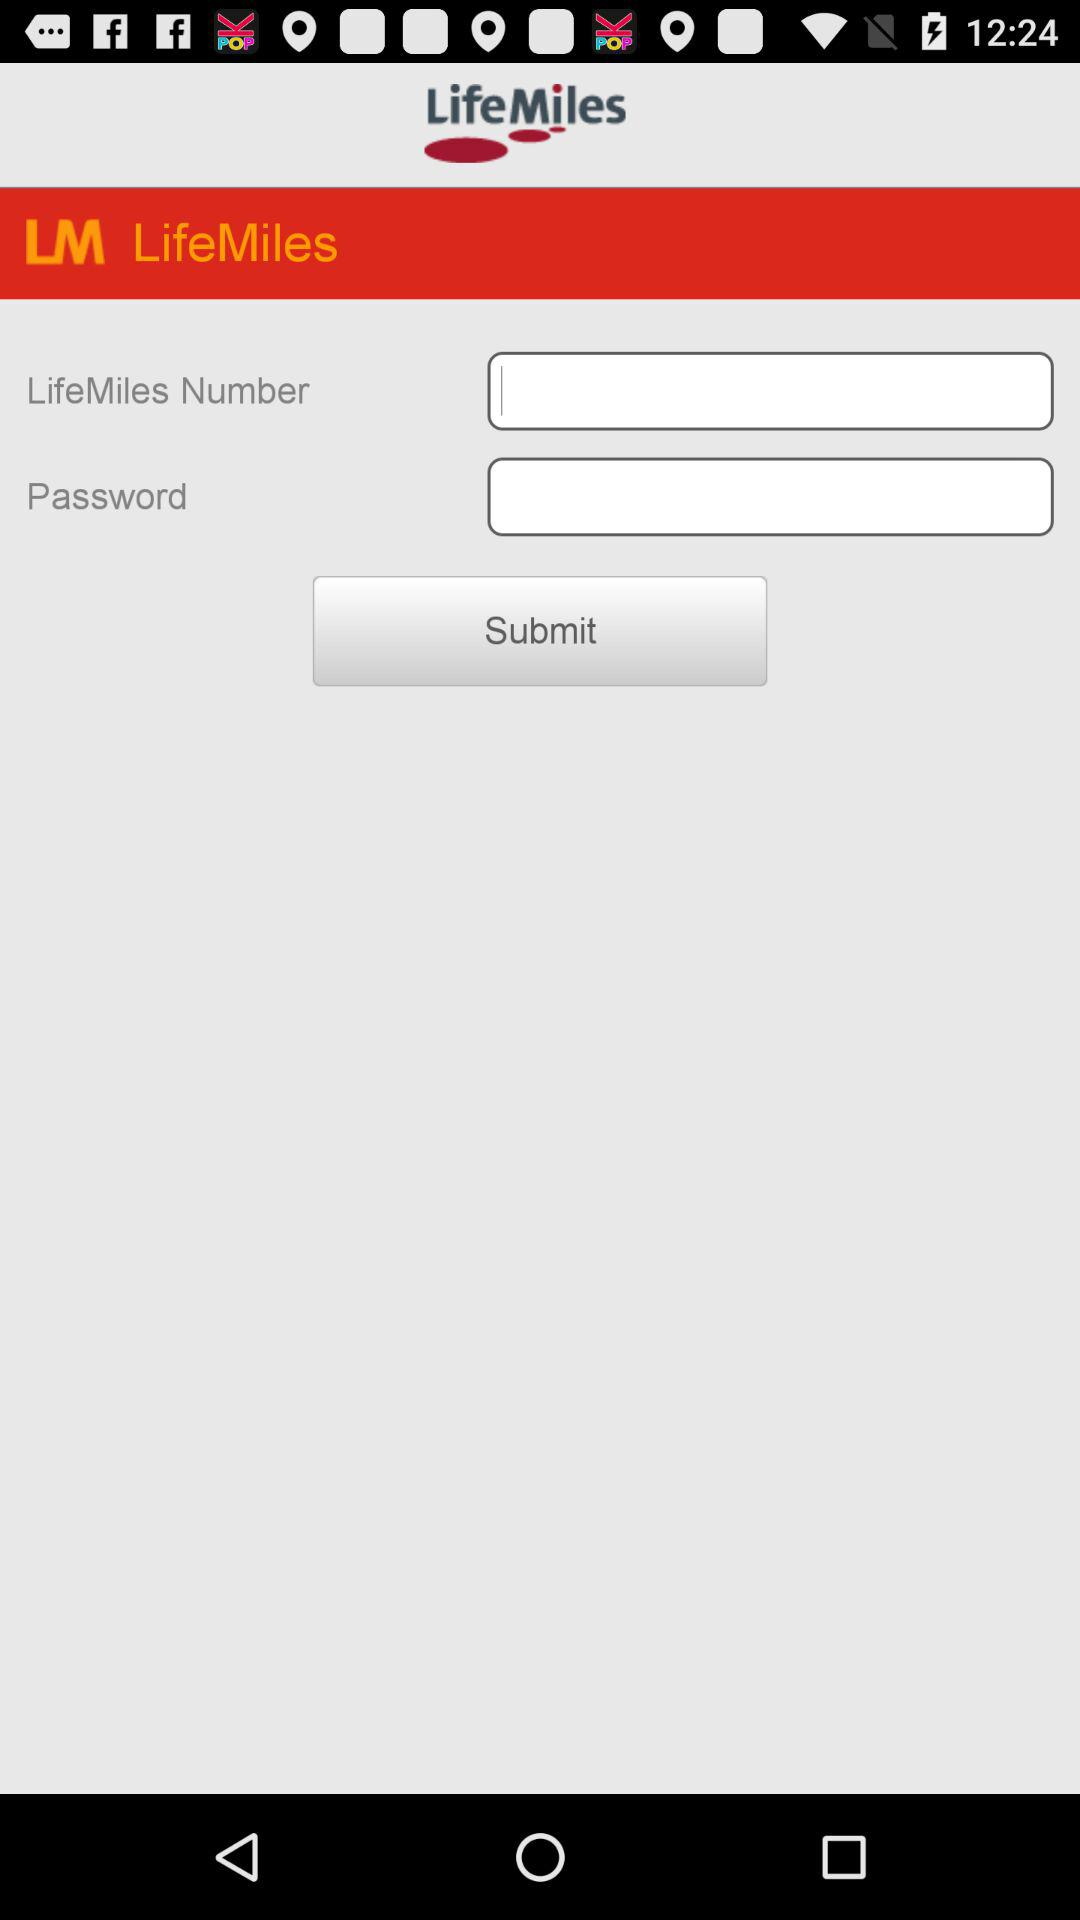What is the name of the application? The name of the application is "LifeMiles". 